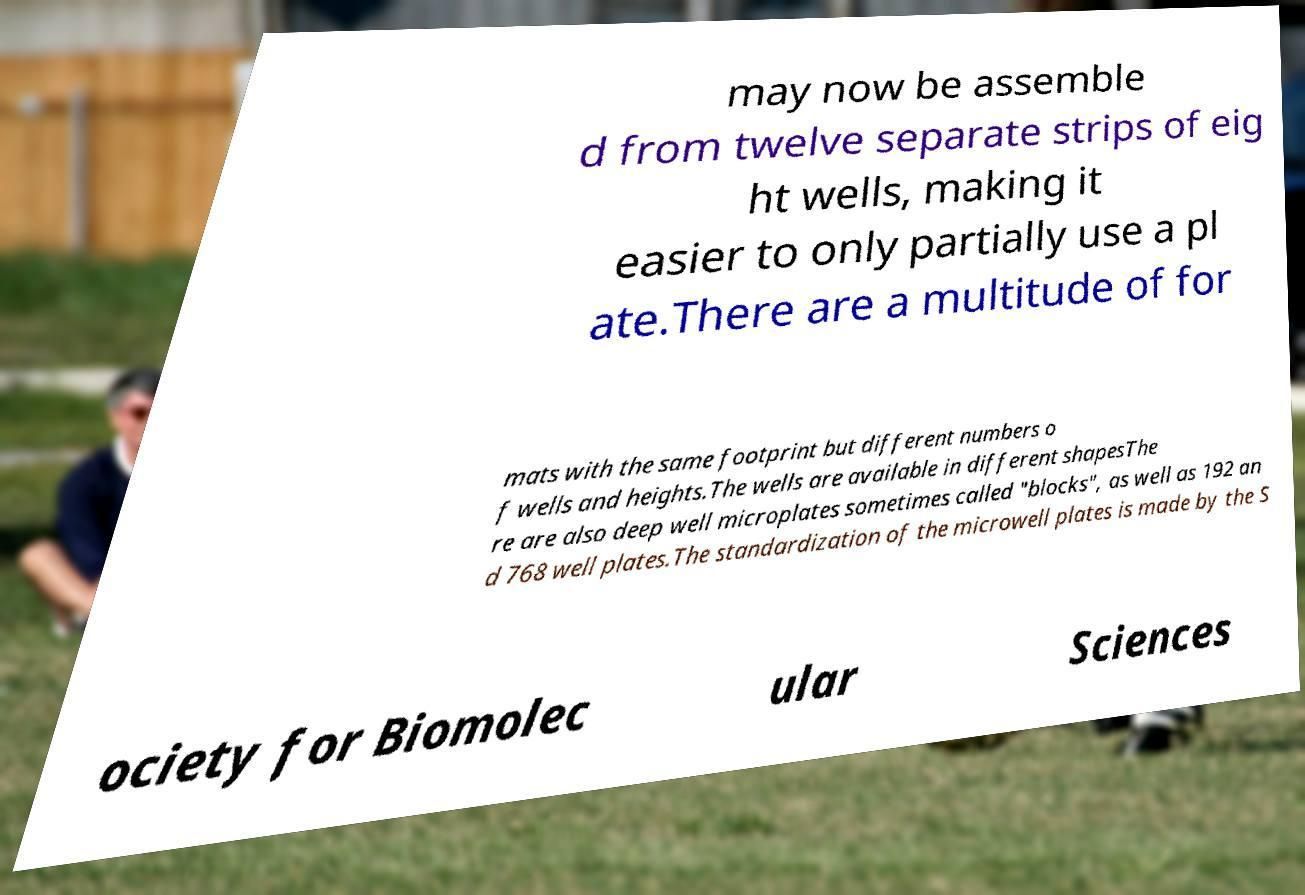For documentation purposes, I need the text within this image transcribed. Could you provide that? may now be assemble d from twelve separate strips of eig ht wells, making it easier to only partially use a pl ate.There are a multitude of for mats with the same footprint but different numbers o f wells and heights.The wells are available in different shapesThe re are also deep well microplates sometimes called "blocks", as well as 192 an d 768 well plates.The standardization of the microwell plates is made by the S ociety for Biomolec ular Sciences 